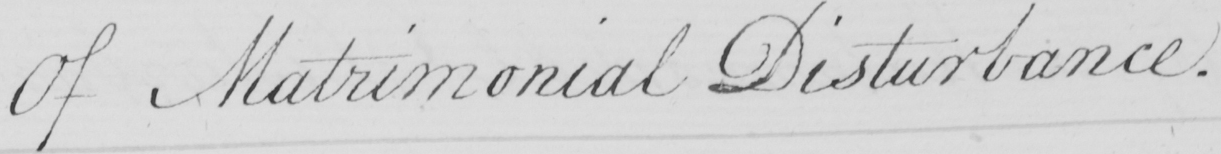What does this handwritten line say? Of Matrimonial Disturbance . 